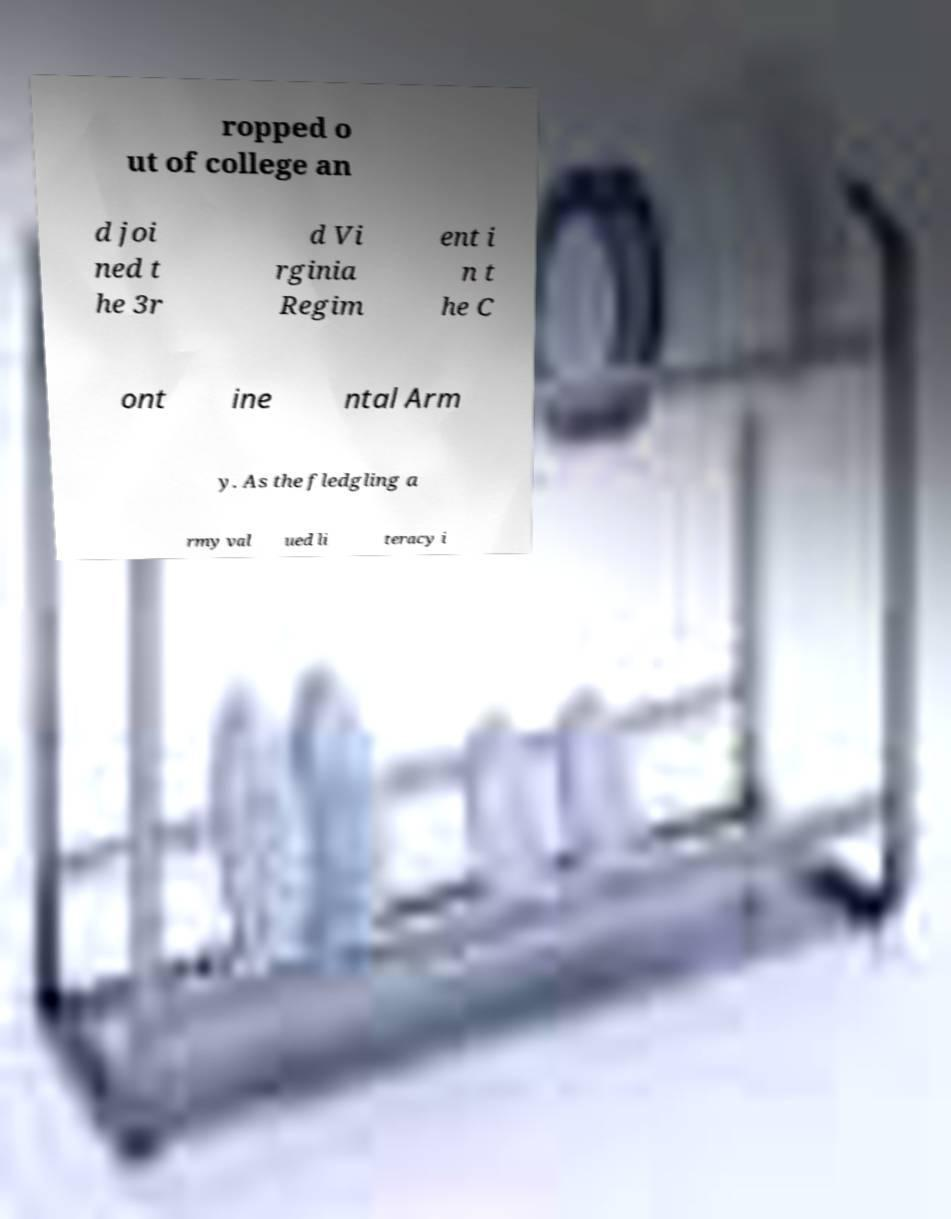Can you accurately transcribe the text from the provided image for me? ropped o ut of college an d joi ned t he 3r d Vi rginia Regim ent i n t he C ont ine ntal Arm y. As the fledgling a rmy val ued li teracy i 